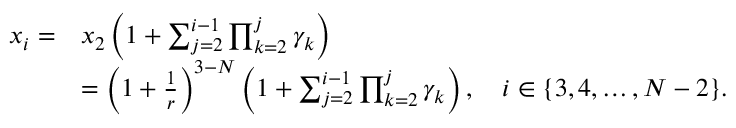Convert formula to latex. <formula><loc_0><loc_0><loc_500><loc_500>\begin{array} { r l } { x _ { i } = } & { x _ { 2 } \left ( 1 + \sum _ { j = 2 } ^ { i - 1 } \prod _ { k = 2 } ^ { j } \gamma _ { k } \right ) } \\ & { = \left ( 1 + \frac { 1 } { r } \right ) ^ { 3 - N } \left ( 1 + \sum _ { j = 2 } ^ { i - 1 } \prod _ { k = 2 } ^ { j } \gamma _ { k } \right ) , \quad i \in \{ 3 , 4 , \dots , N - 2 \} . } \end{array}</formula> 